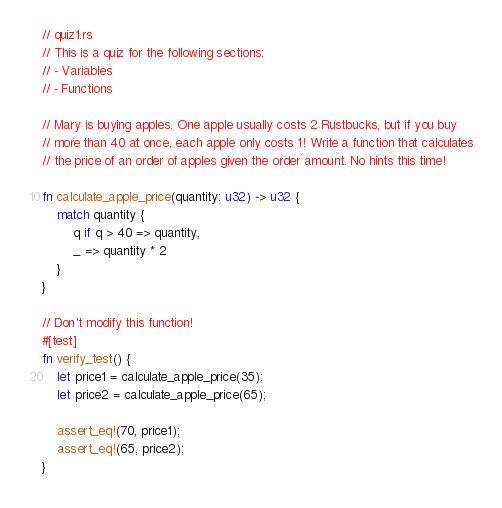Convert code to text. <code><loc_0><loc_0><loc_500><loc_500><_Rust_>// quiz1.rs
// This is a quiz for the following sections:
// - Variables
// - Functions

// Mary is buying apples. One apple usually costs 2 Rustbucks, but if you buy
// more than 40 at once, each apple only costs 1! Write a function that calculates
// the price of an order of apples given the order amount. No hints this time!

fn calculate_apple_price(quantity: u32) -> u32 {
    match quantity {
        q if q > 40 => quantity,
        _ => quantity * 2
    }
}

// Don't modify this function!
#[test]
fn verify_test() {
    let price1 = calculate_apple_price(35);
    let price2 = calculate_apple_price(65);

    assert_eq!(70, price1);
    assert_eq!(65, price2);
}
</code> 